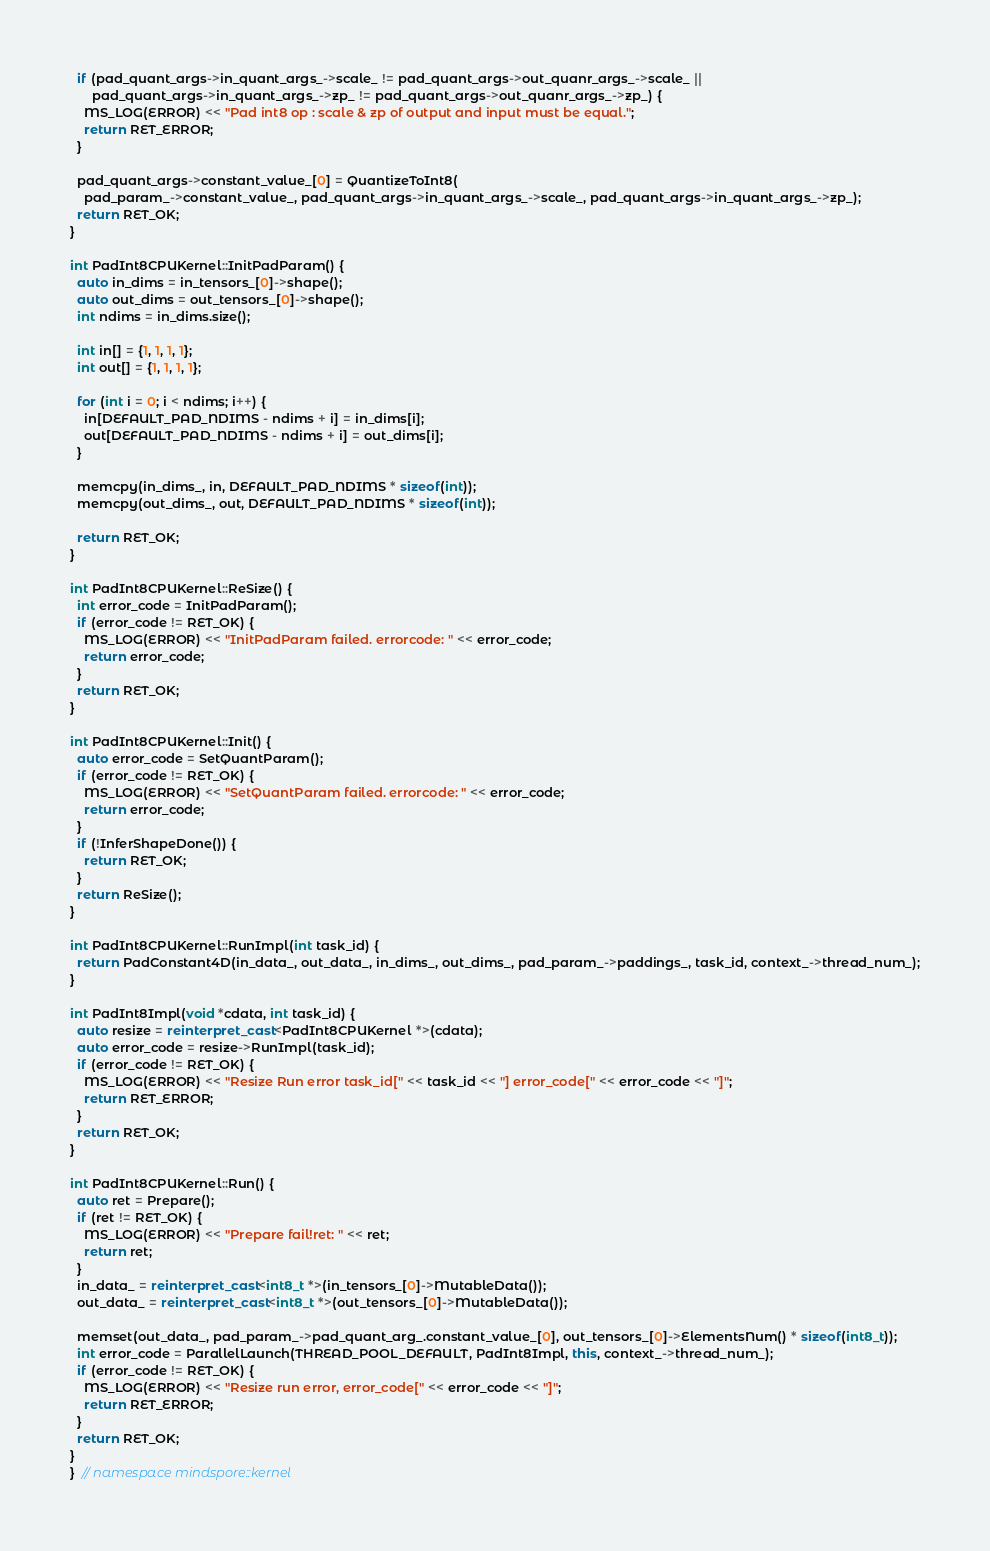Convert code to text. <code><loc_0><loc_0><loc_500><loc_500><_C++_>  if (pad_quant_args->in_quant_args_->scale_ != pad_quant_args->out_quanr_args_->scale_ ||
      pad_quant_args->in_quant_args_->zp_ != pad_quant_args->out_quanr_args_->zp_) {
    MS_LOG(ERROR) << "Pad int8 op : scale & zp of output and input must be equal.";
    return RET_ERROR;
  }

  pad_quant_args->constant_value_[0] = QuantizeToInt8(
    pad_param_->constant_value_, pad_quant_args->in_quant_args_->scale_, pad_quant_args->in_quant_args_->zp_);
  return RET_OK;
}

int PadInt8CPUKernel::InitPadParam() {
  auto in_dims = in_tensors_[0]->shape();
  auto out_dims = out_tensors_[0]->shape();
  int ndims = in_dims.size();

  int in[] = {1, 1, 1, 1};
  int out[] = {1, 1, 1, 1};

  for (int i = 0; i < ndims; i++) {
    in[DEFAULT_PAD_NDIMS - ndims + i] = in_dims[i];
    out[DEFAULT_PAD_NDIMS - ndims + i] = out_dims[i];
  }

  memcpy(in_dims_, in, DEFAULT_PAD_NDIMS * sizeof(int));
  memcpy(out_dims_, out, DEFAULT_PAD_NDIMS * sizeof(int));

  return RET_OK;
}

int PadInt8CPUKernel::ReSize() {
  int error_code = InitPadParam();
  if (error_code != RET_OK) {
    MS_LOG(ERROR) << "InitPadParam failed. errorcode: " << error_code;
    return error_code;
  }
  return RET_OK;
}

int PadInt8CPUKernel::Init() {
  auto error_code = SetQuantParam();
  if (error_code != RET_OK) {
    MS_LOG(ERROR) << "SetQuantParam failed. errorcode: " << error_code;
    return error_code;
  }
  if (!InferShapeDone()) {
    return RET_OK;
  }
  return ReSize();
}

int PadInt8CPUKernel::RunImpl(int task_id) {
  return PadConstant4D(in_data_, out_data_, in_dims_, out_dims_, pad_param_->paddings_, task_id, context_->thread_num_);
}

int PadInt8Impl(void *cdata, int task_id) {
  auto resize = reinterpret_cast<PadInt8CPUKernel *>(cdata);
  auto error_code = resize->RunImpl(task_id);
  if (error_code != RET_OK) {
    MS_LOG(ERROR) << "Resize Run error task_id[" << task_id << "] error_code[" << error_code << "]";
    return RET_ERROR;
  }
  return RET_OK;
}

int PadInt8CPUKernel::Run() {
  auto ret = Prepare();
  if (ret != RET_OK) {
    MS_LOG(ERROR) << "Prepare fail!ret: " << ret;
    return ret;
  }
  in_data_ = reinterpret_cast<int8_t *>(in_tensors_[0]->MutableData());
  out_data_ = reinterpret_cast<int8_t *>(out_tensors_[0]->MutableData());

  memset(out_data_, pad_param_->pad_quant_arg_.constant_value_[0], out_tensors_[0]->ElementsNum() * sizeof(int8_t));
  int error_code = ParallelLaunch(THREAD_POOL_DEFAULT, PadInt8Impl, this, context_->thread_num_);
  if (error_code != RET_OK) {
    MS_LOG(ERROR) << "Resize run error, error_code[" << error_code << "]";
    return RET_ERROR;
  }
  return RET_OK;
}
}  // namespace mindspore::kernel
</code> 